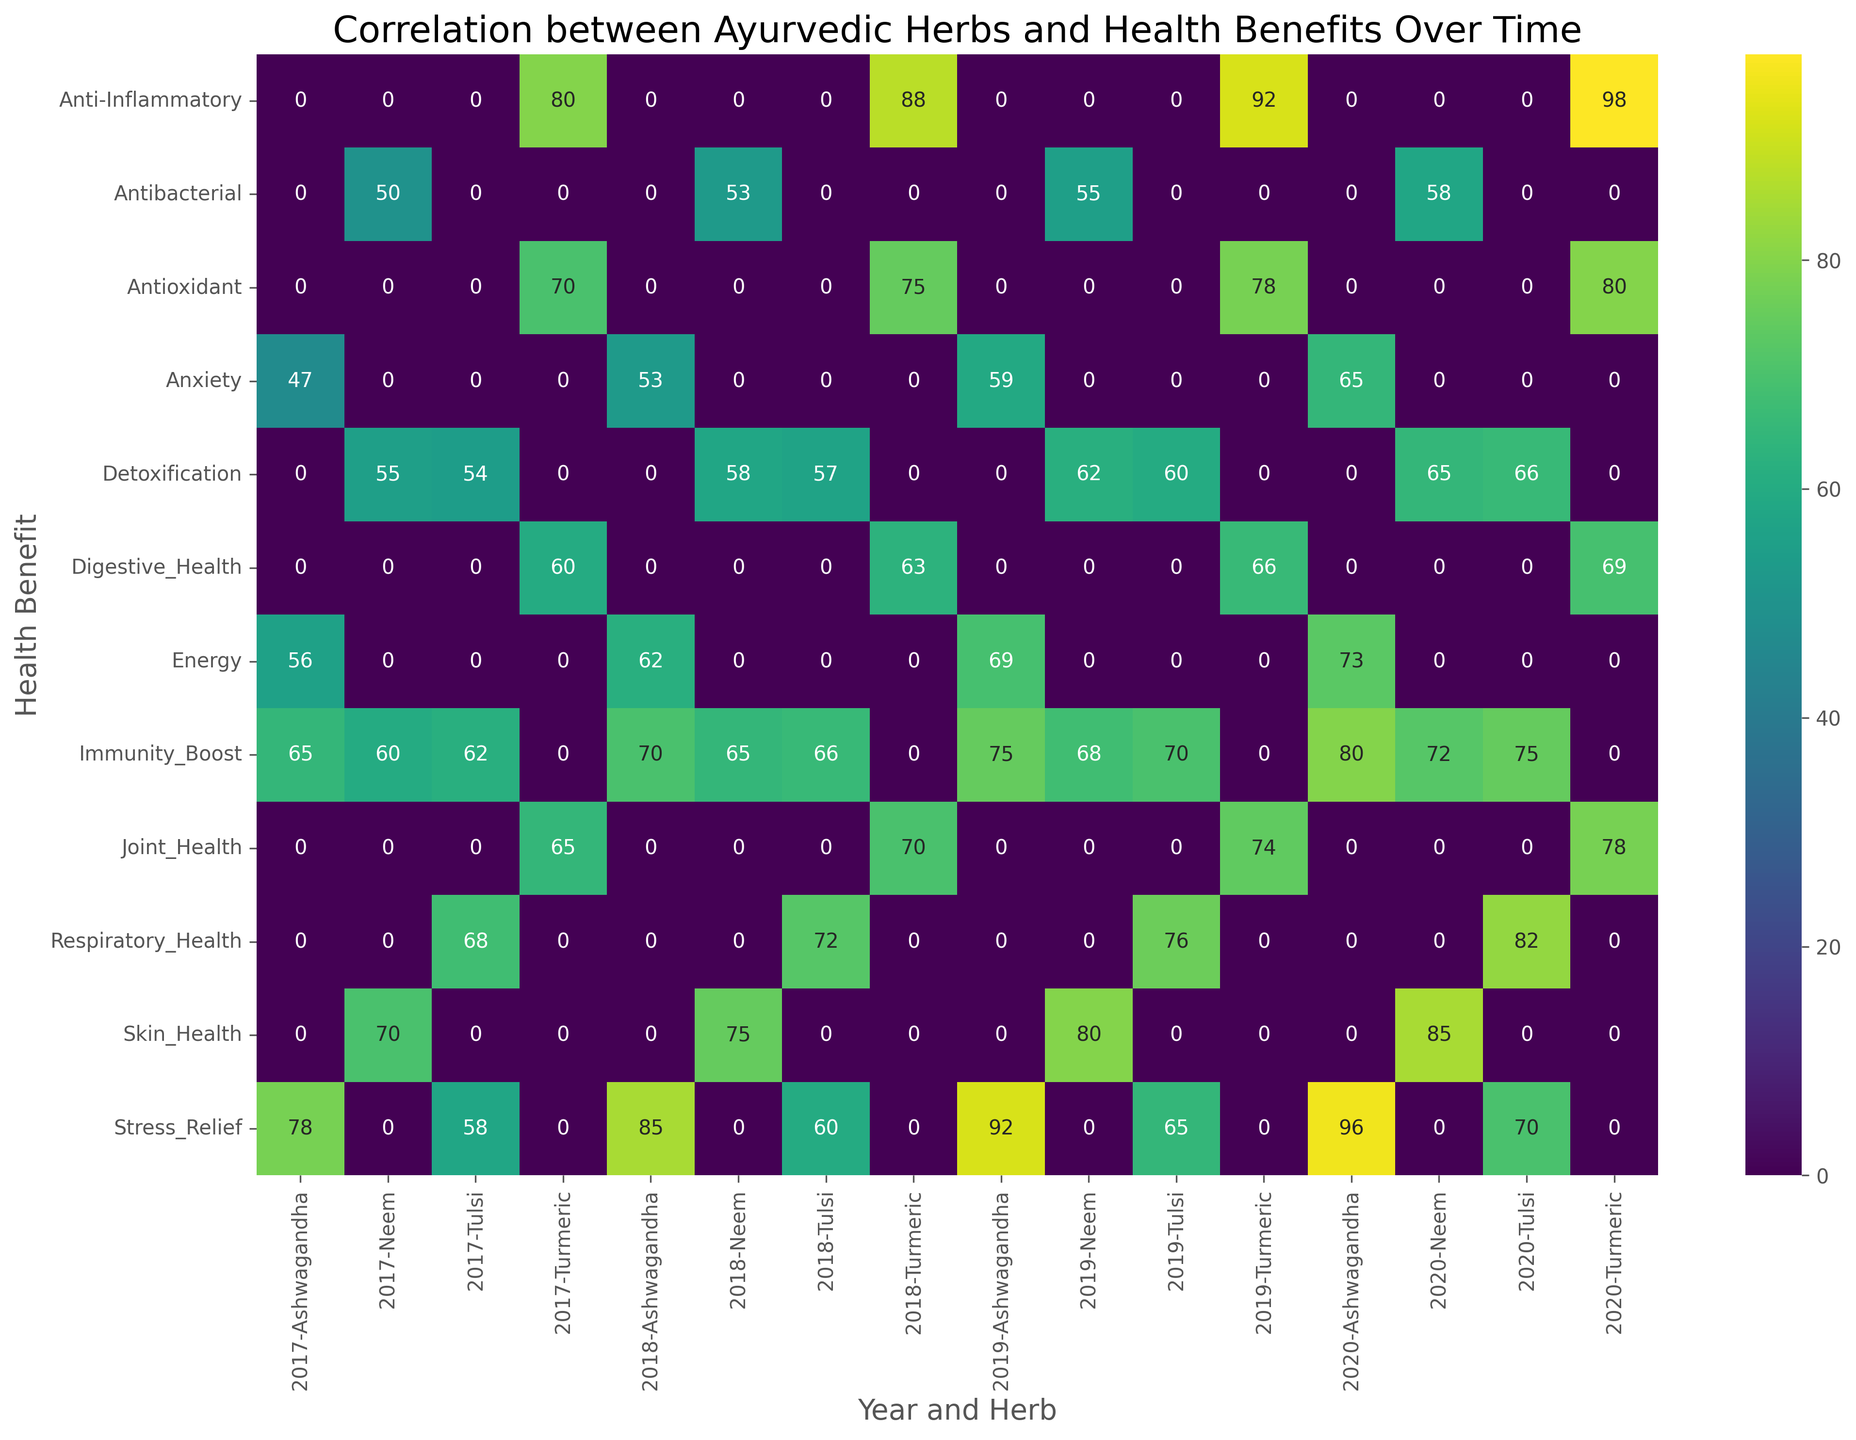What's the most frequently indicated health benefit of Ashwagandha in 2020? To find this, look at the row labeled "Ashwagandha" under column "2020" and find the highest number in the columns for different health benefits. The highest value is in the "Stress_Relief" column, which is 96.
Answer: Stress_Relief Which herb had the highest frequency for the Anti-Inflammatory benefit in 2019? Locate the "Anti-Inflammatory" row and look under the "2019" columns for the highest number under the "Herb" headers. Turmeric has the highest value of 92.
Answer: Turmeric What is the average frequency of the Immunity Boost benefit from Neem and Tulsi in 2018? Under the "2018" column, find the "Immunity_Boost" values for Neem and Tulsi. These values are 65 for Neem and 66 for Tulsi. The average is (65 + 66) / 2 = 65.5.
Answer: 65.5 Did any herb have an increase in Detoxification frequency every year from 2017 to 2020? Check the "Detoxification" rows for consistent year-over-year increases for any herb. Tulsi's values in these years are 54 (2017), 57 (2018), 60 (2019), and 66 (2020), showing a consistent increase.
Answer: Tulsi Which herb and health benefit combination has the highest frequency in 2019? Find the highest value in the "2019" columns. The highest value is in the row "Anti-Inflammatory" under Turmeric, which is 92.
Answer: Turmeric, Anti-Inflammatory What's the difference in the frequency of Joint Health benefit from 2017 to 2018 for Turmeric? Look at the "Joint_Health" row for years 2017 and 2018 under Turmeric. The values are 65 (2017) and 70 (2018). The difference is 70 - 65 = 5.
Answer: 5 Which health benefit and year shows the least interest in Neem as compared to others? Look for the smallest number in rows corresponding to "Neem" for all years. The smallest number is in 2017 under "Antibacterial" which is 50.
Answer: Antibacterial, 2017 Compare the frequency of Stress Relief benefit for Ashwagandha and Tulsi in 2018. Which one has a higher frequency? Look at the "Stress_Relief" row for 2018 under Ashwagandha and Tulsi. Ashwagandha has 85, and Tulsi has 60. Ashwagandha has the higher frequency.
Answer: Ashwagandha 